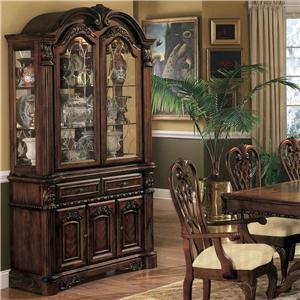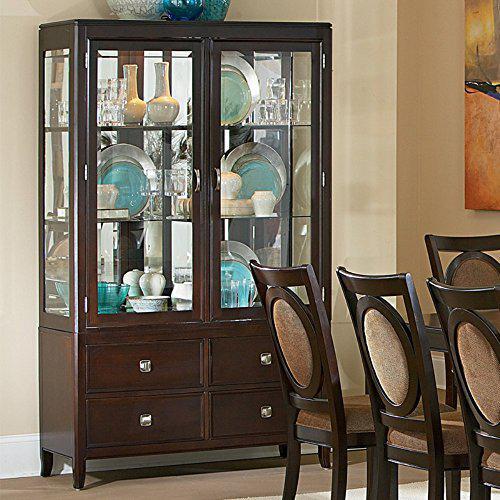The first image is the image on the left, the second image is the image on the right. Given the left and right images, does the statement "Wooden china cabinets in both images are dark and ornate with curved details." hold true? Answer yes or no. No. The first image is the image on the left, the second image is the image on the right. Considering the images on both sides, is "There is a brown chair with white seat." valid? Answer yes or no. Yes. 